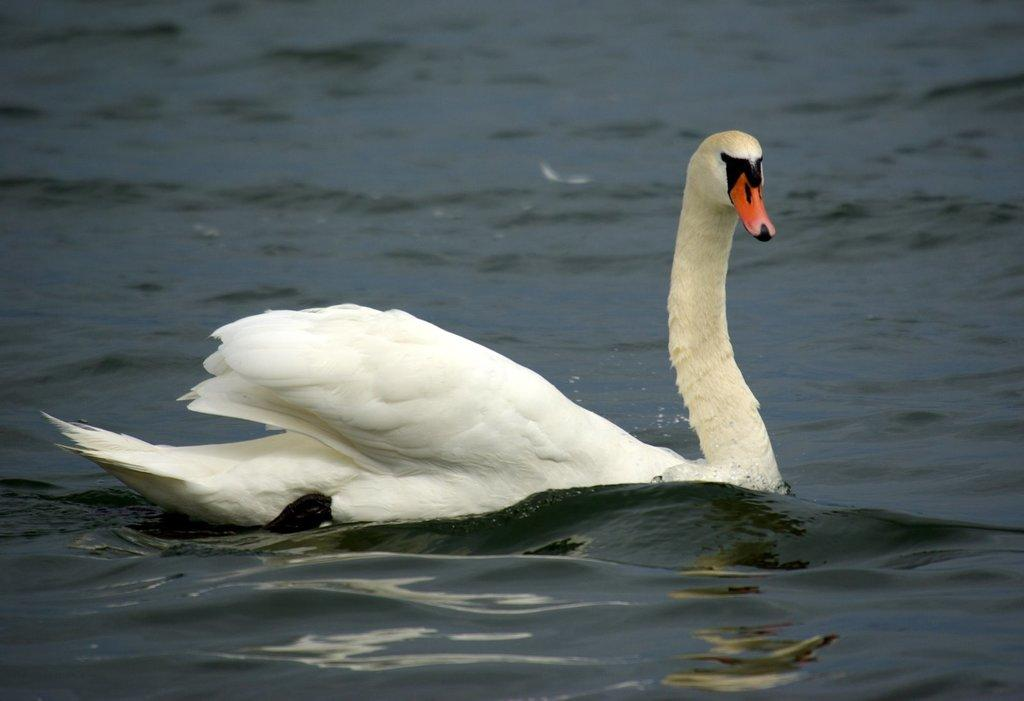What animal is present in the image? There is a swan in the image. Where is the swan located? The swan is in a water body. What type of locket is the swan holding in the image? There is no locket present in the image, as it features a swan in a water body. 